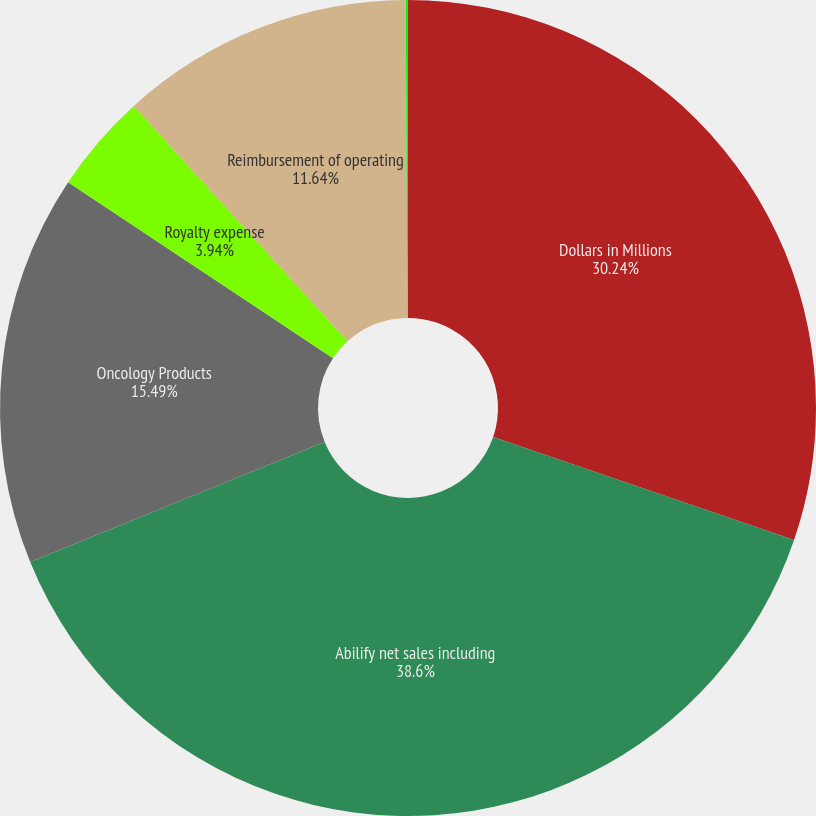Convert chart to OTSL. <chart><loc_0><loc_0><loc_500><loc_500><pie_chart><fcel>Dollars in Millions<fcel>Abilify net sales including<fcel>Oncology Products<fcel>Royalty expense<fcel>Reimbursement of operating<fcel>Amortization (income)/expense<nl><fcel>30.24%<fcel>38.59%<fcel>15.49%<fcel>3.94%<fcel>11.64%<fcel>0.09%<nl></chart> 